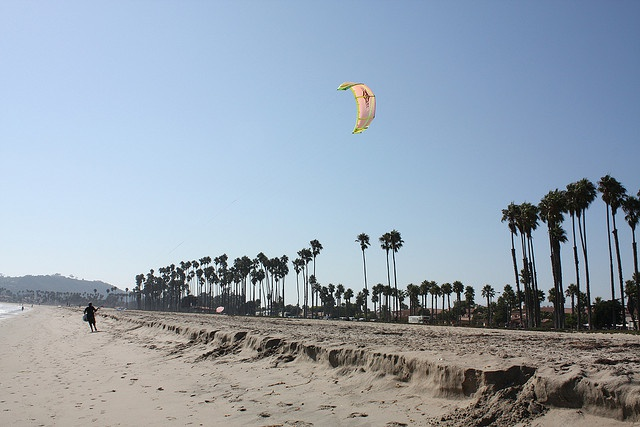Describe the objects in this image and their specific colors. I can see kite in lavender, lightpink, lightblue, tan, and darkgray tones, people in lavender, black, maroon, gray, and brown tones, truck in lavender, black, darkgray, gray, and lightgray tones, and people in lavender, darkblue, black, and gray tones in this image. 